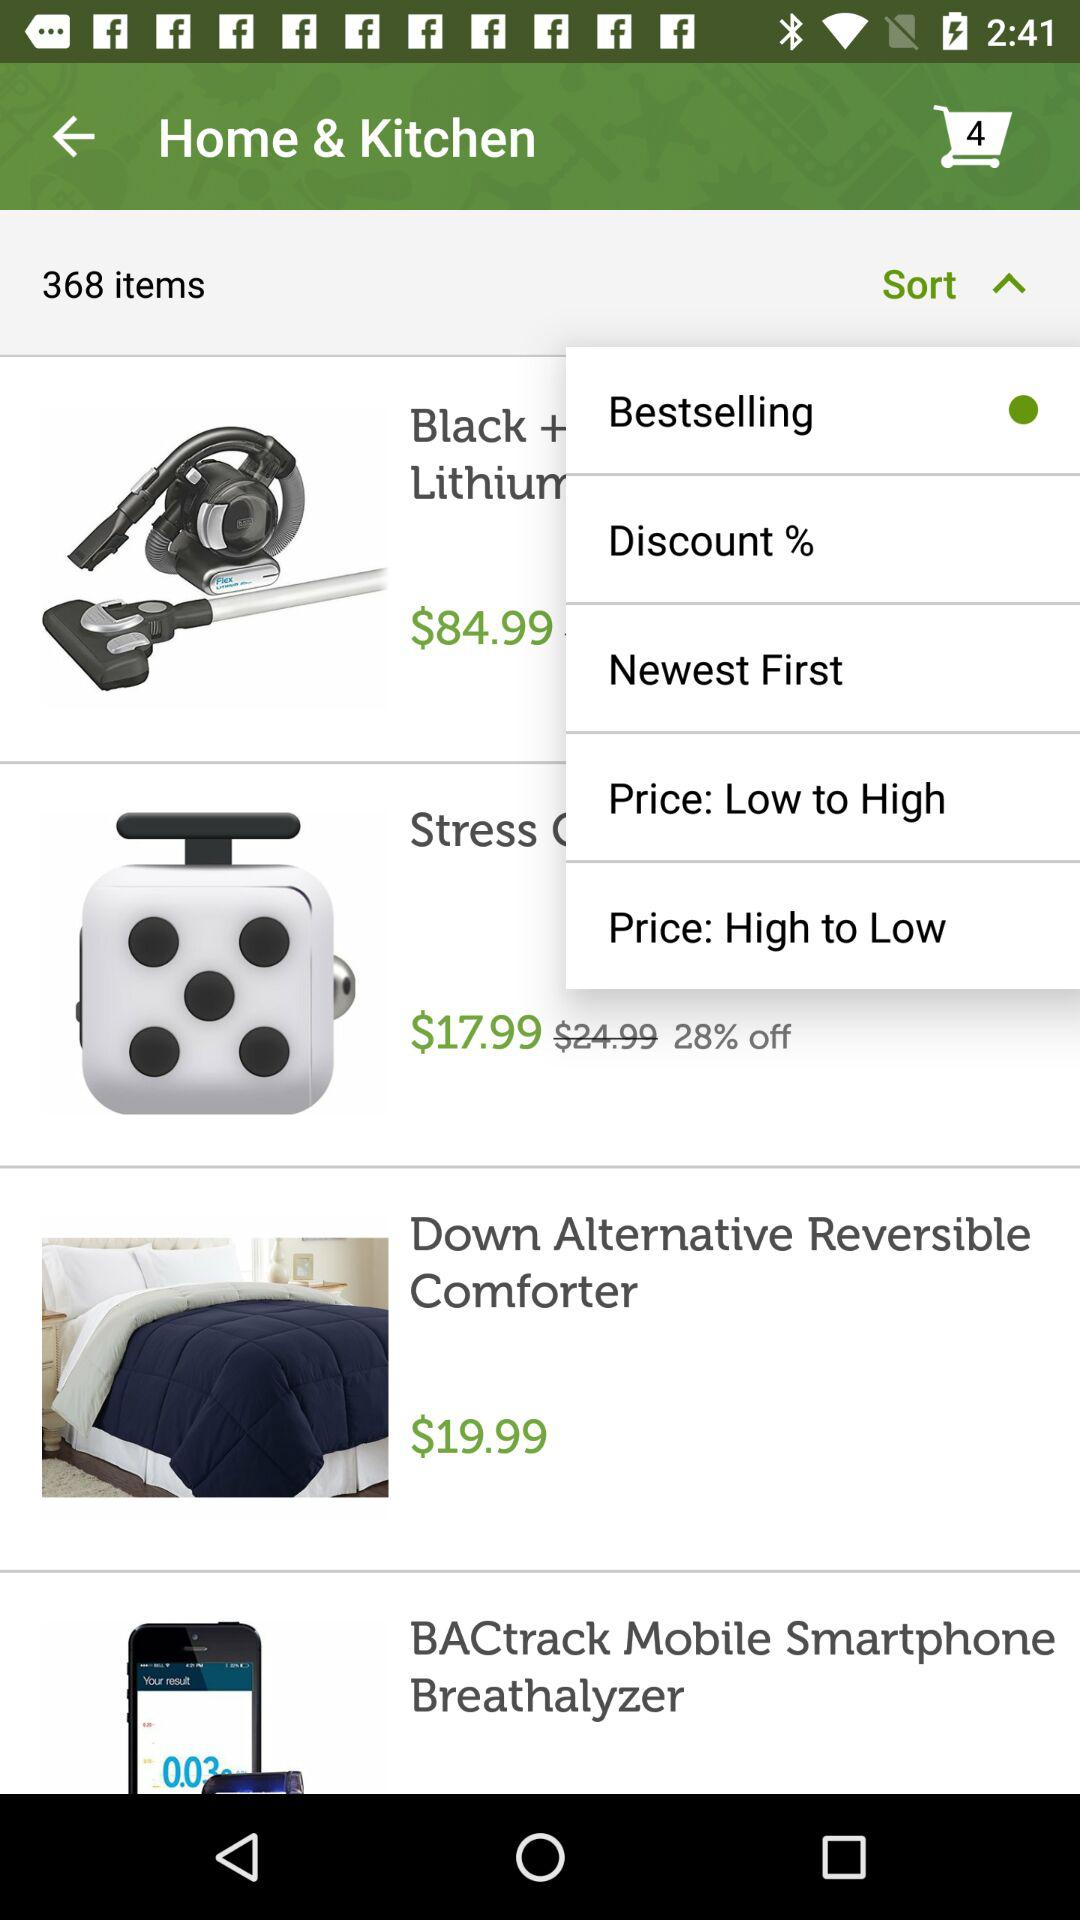What is the price of the "Down Alternative Reversible Comforter"? The price is $19.99. 